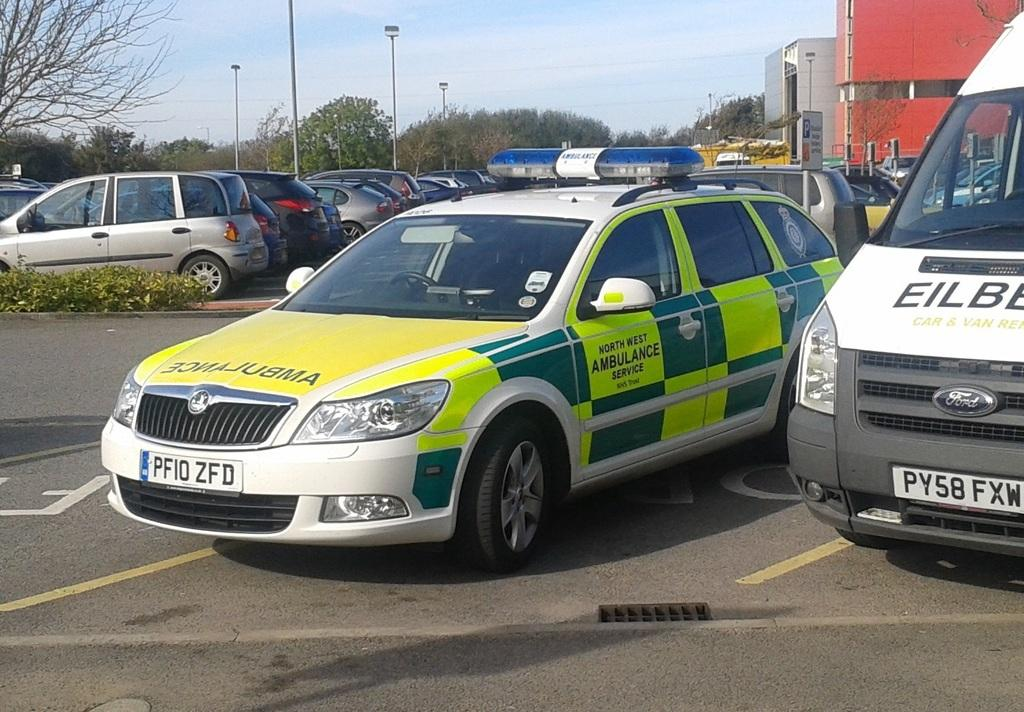What can be seen on the road in the image? There are cars parked on the road in the image. What type of vegetation is visible in the image? There are trees visible in the image. What type of structures can be seen in the image? There are buildings in the image. Can you tell me how many crows are sitting on the stage in the image? There is no stage or crows present in the image; it features cars parked on the road, trees, and buildings. What type of pot is being used by the crow in the image? There is no crow or pot present in the image. 